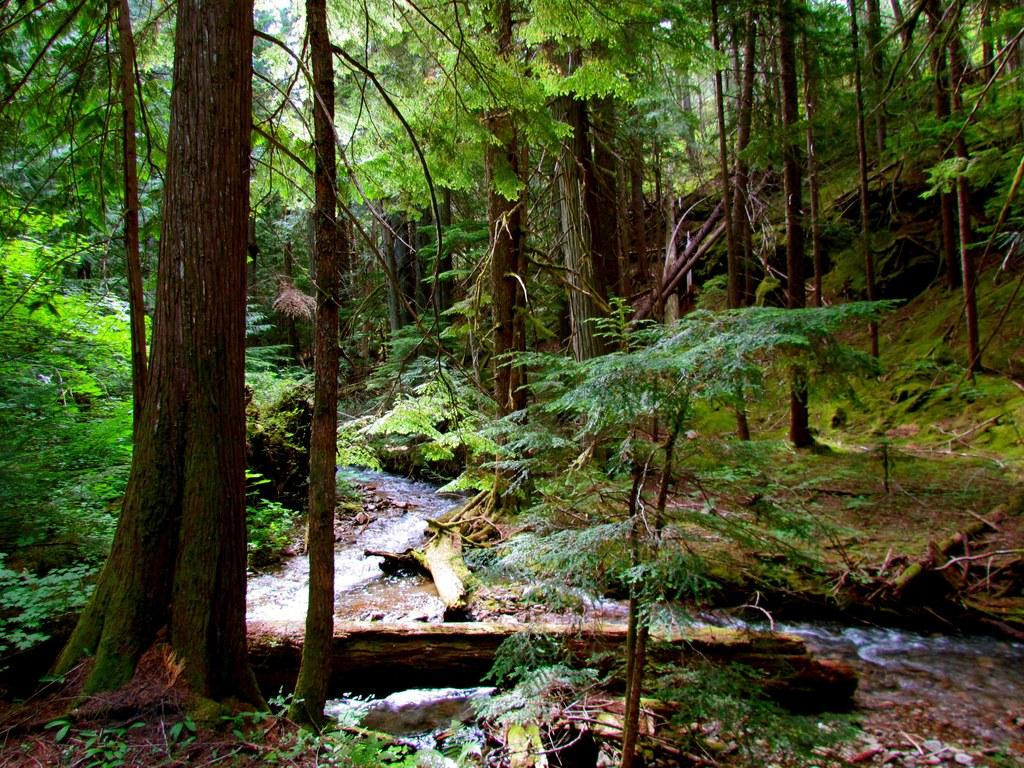What is visible in the image? Water, the ground, plants, and trees are visible in the image. Can you describe the natural elements present in the image? The image features water, plants, and trees, which are all natural elements. What type of terrain is visible in the image? The ground is visible in the image, which suggests a type of terrain. What type of shock can be seen in the image? There is no shock present in the image. Can you describe the balloon floating in the image? There is no balloon present in the image. 